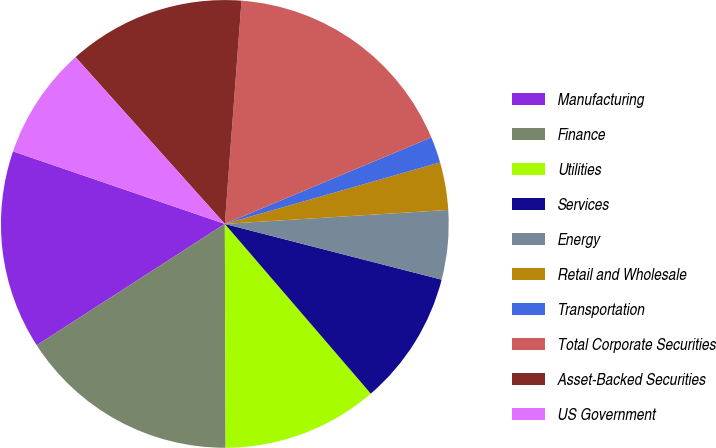Convert chart. <chart><loc_0><loc_0><loc_500><loc_500><pie_chart><fcel>Manufacturing<fcel>Finance<fcel>Utilities<fcel>Services<fcel>Energy<fcel>Retail and Wholesale<fcel>Transportation<fcel>Total Corporate Securities<fcel>Asset-Backed Securities<fcel>US Government<nl><fcel>14.37%<fcel>15.94%<fcel>11.25%<fcel>9.69%<fcel>5.0%<fcel>3.44%<fcel>1.88%<fcel>17.5%<fcel>12.81%<fcel>8.13%<nl></chart> 